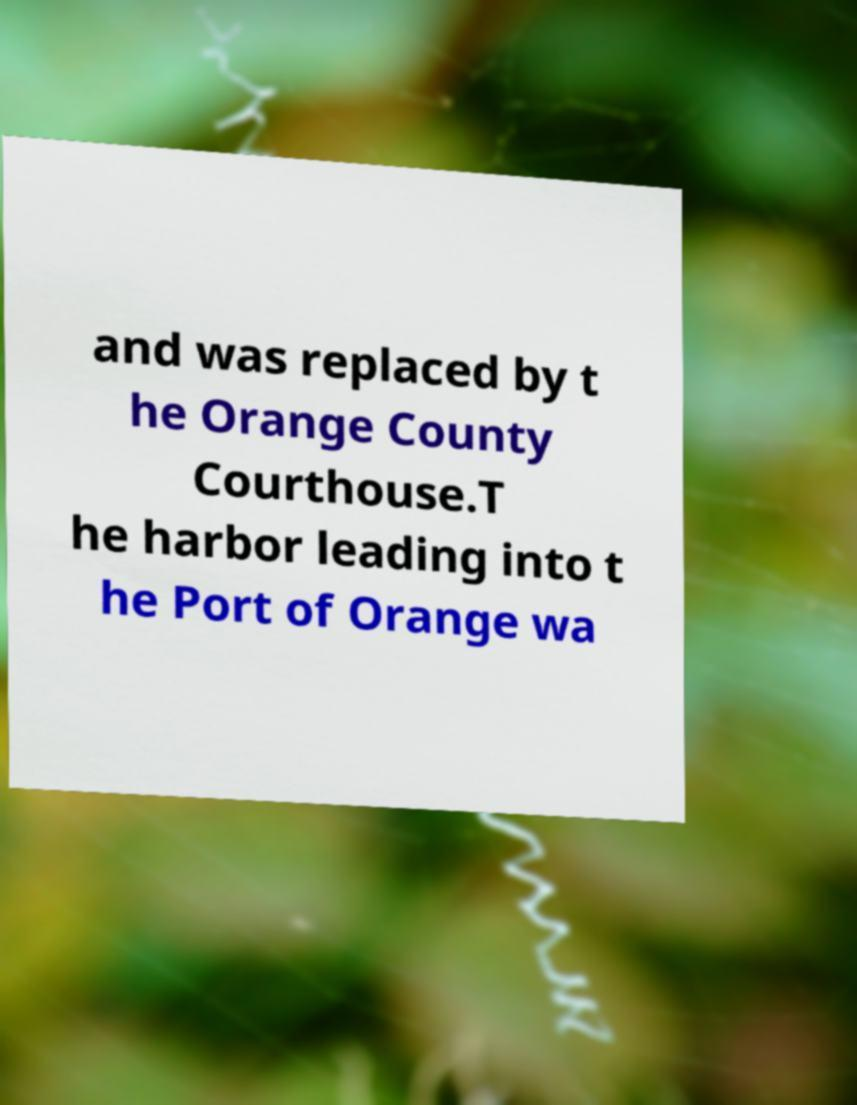There's text embedded in this image that I need extracted. Can you transcribe it verbatim? and was replaced by t he Orange County Courthouse.T he harbor leading into t he Port of Orange wa 